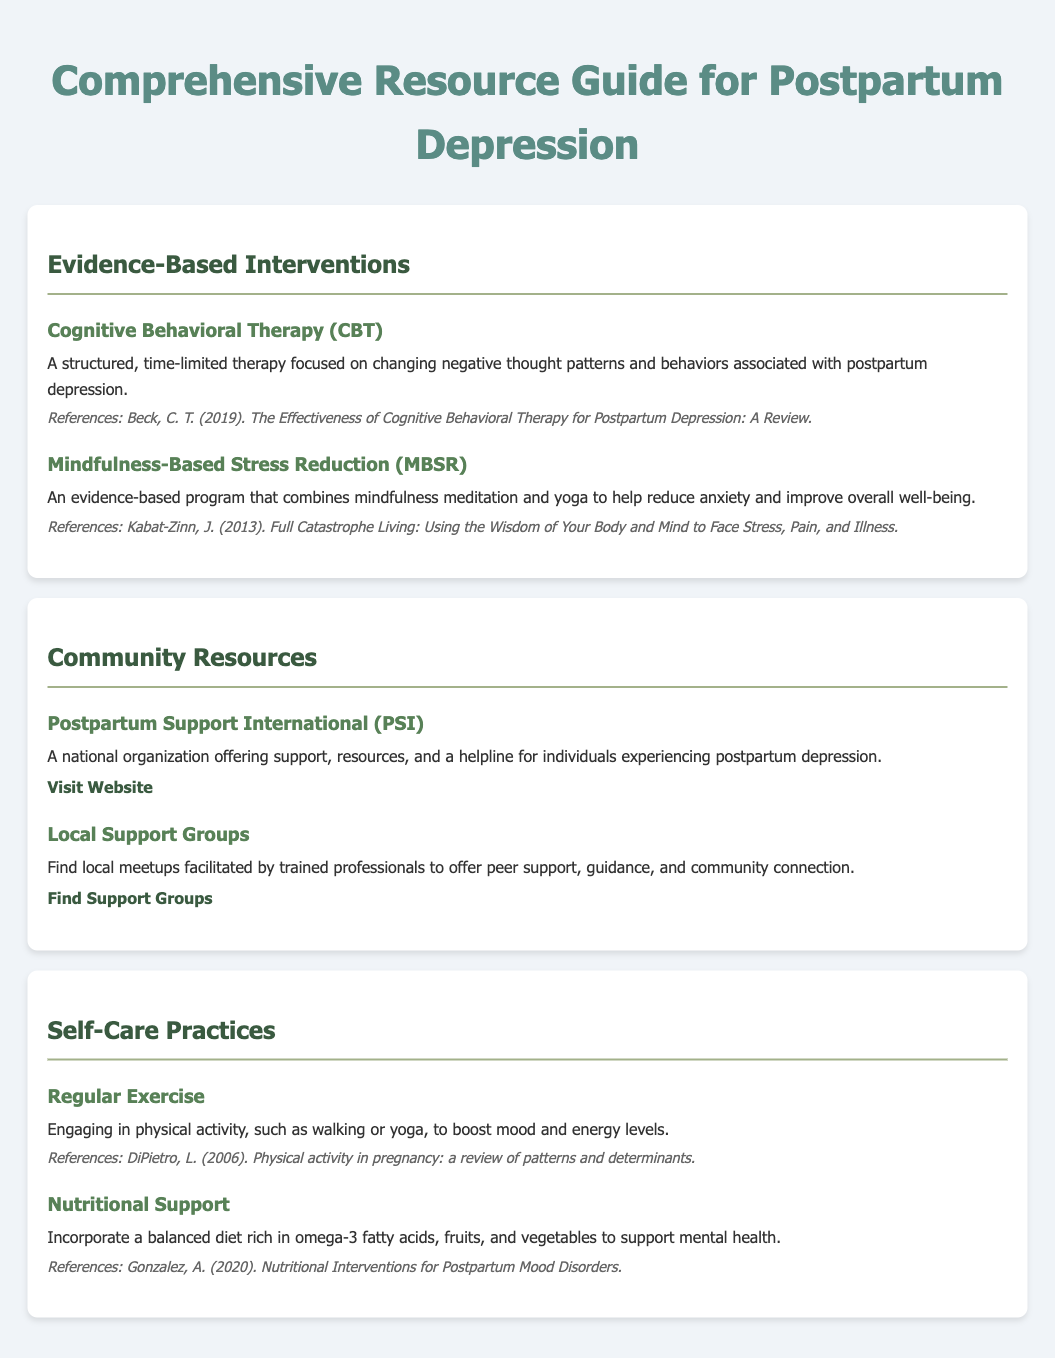What is the title of the document? The title of the document is stated at the top of the rendered page.
Answer: Comprehensive Resource Guide for Postpartum Depression How many evidence-based interventions are listed? The section titled "Evidence-Based Interventions" contains a total of two different interventions.
Answer: 2 What is one type of therapy mentioned under evidence-based interventions? The document lists specific therapies within the "Evidence-Based Interventions" section.
Answer: Cognitive Behavioral Therapy Which organization offers resources for postpartum depression? The "Community Resources" section contains an organization offering support.
Answer: Postpartum Support International What activity is suggested as a self-care practice? The "Self-Care Practices" section provides specific activities that can boost mood and well-being.
Answer: Regular Exercise What is the website for local support groups? The document mentions a website link under "Local Support Groups" for finding support.
Answer: https://www.motherhoodcenter.com/support-groups/ Who authored the referenced effectiveness of CBT for postpartum depression? The reference section of the first intervention details the author.
Answer: Beck, C. T Which dietary component is emphasized for nutritional support? The section on nutritional support highlights a specific type of fatty acid beneficial for mental health.
Answer: Omega-3 fatty acids 